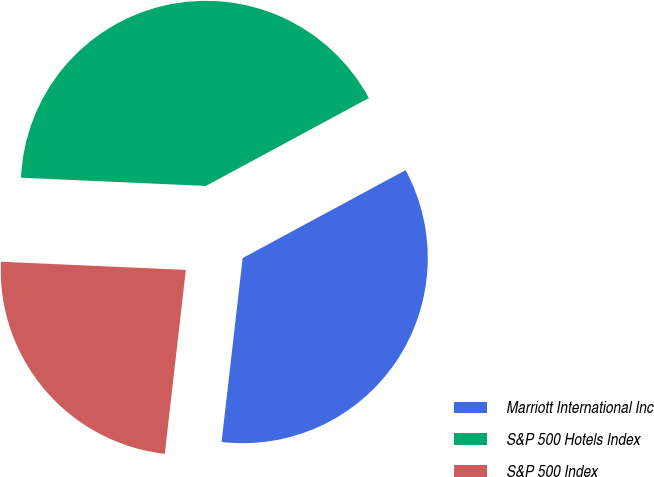Convert chart to OTSL. <chart><loc_0><loc_0><loc_500><loc_500><pie_chart><fcel>Marriott International Inc<fcel>S&P 500 Hotels Index<fcel>S&P 500 Index<nl><fcel>34.69%<fcel>41.42%<fcel>23.89%<nl></chart> 